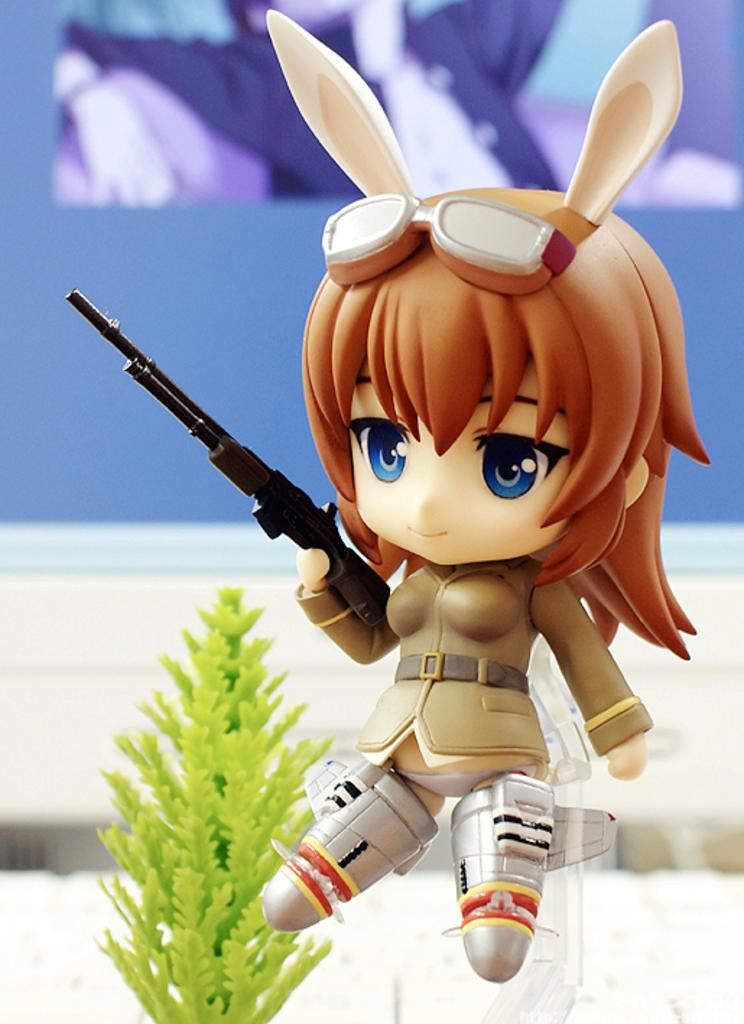What type of toy is depicted in the image? There is a toy in the shape of a girl holding a gun in the image. What can be seen on the left side of the image? There is a plastic plant on the left side of the image. Where is the jar of sea water located in the image? There is no jar of sea water present in the image. What type of bomb is visible in the image? There is no bomb present in the image. 